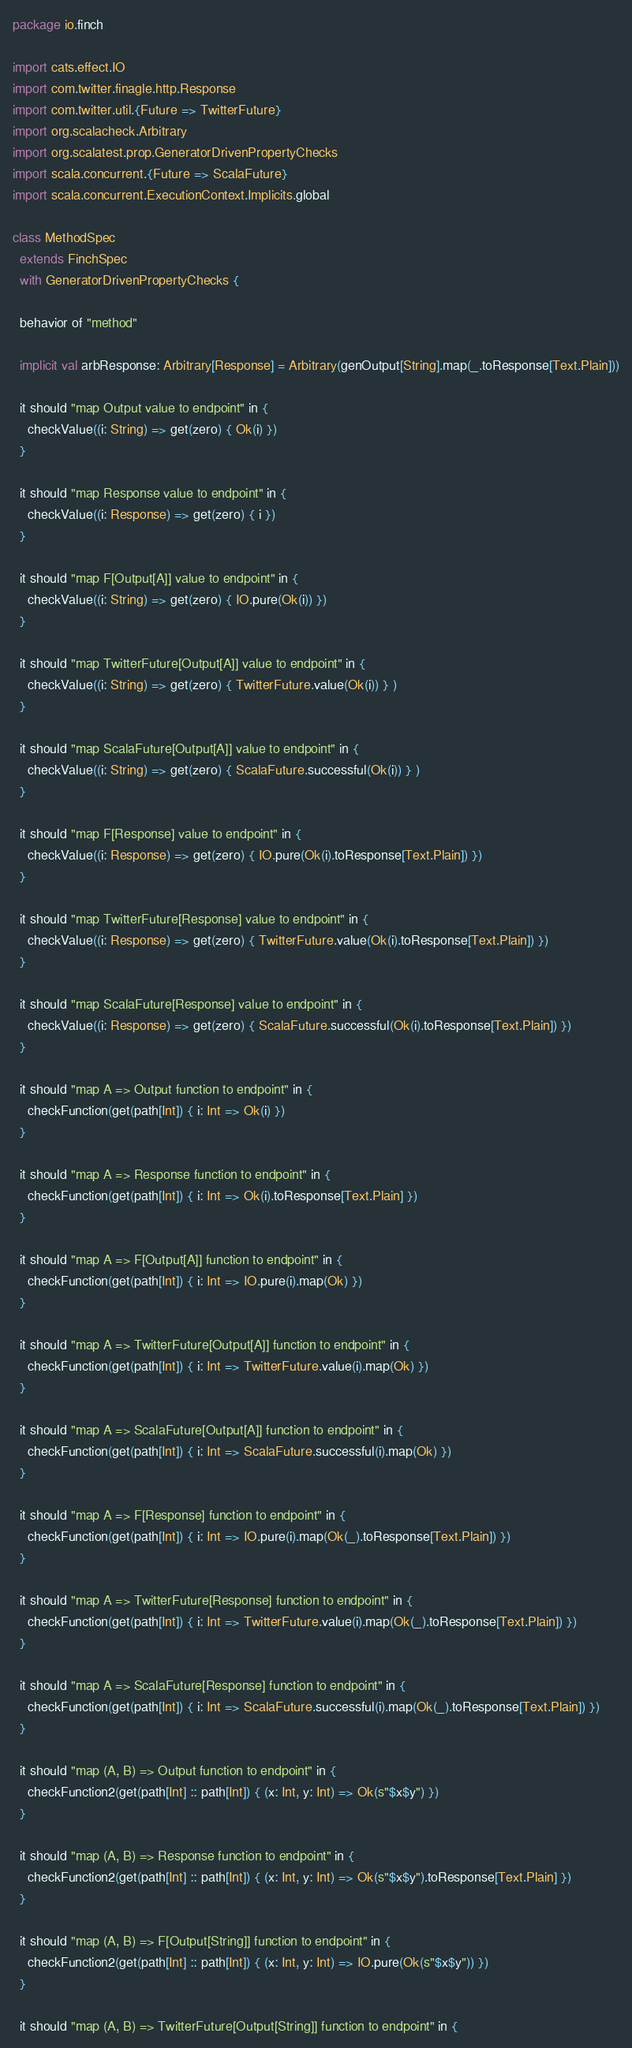Convert code to text. <code><loc_0><loc_0><loc_500><loc_500><_Scala_>package io.finch

import cats.effect.IO
import com.twitter.finagle.http.Response
import com.twitter.util.{Future => TwitterFuture}
import org.scalacheck.Arbitrary
import org.scalatest.prop.GeneratorDrivenPropertyChecks
import scala.concurrent.{Future => ScalaFuture}
import scala.concurrent.ExecutionContext.Implicits.global

class MethodSpec
  extends FinchSpec
  with GeneratorDrivenPropertyChecks {

  behavior of "method"

  implicit val arbResponse: Arbitrary[Response] = Arbitrary(genOutput[String].map(_.toResponse[Text.Plain]))

  it should "map Output value to endpoint" in {
    checkValue((i: String) => get(zero) { Ok(i) })
  }

  it should "map Response value to endpoint" in {
    checkValue((i: Response) => get(zero) { i })
  }

  it should "map F[Output[A]] value to endpoint" in {
    checkValue((i: String) => get(zero) { IO.pure(Ok(i)) })
  }

  it should "map TwitterFuture[Output[A]] value to endpoint" in {
    checkValue((i: String) => get(zero) { TwitterFuture.value(Ok(i)) } )
  }

  it should "map ScalaFuture[Output[A]] value to endpoint" in {
    checkValue((i: String) => get(zero) { ScalaFuture.successful(Ok(i)) } )
  }

  it should "map F[Response] value to endpoint" in {
    checkValue((i: Response) => get(zero) { IO.pure(Ok(i).toResponse[Text.Plain]) })
  }

  it should "map TwitterFuture[Response] value to endpoint" in {
    checkValue((i: Response) => get(zero) { TwitterFuture.value(Ok(i).toResponse[Text.Plain]) })
  }

  it should "map ScalaFuture[Response] value to endpoint" in {
    checkValue((i: Response) => get(zero) { ScalaFuture.successful(Ok(i).toResponse[Text.Plain]) })
  }

  it should "map A => Output function to endpoint" in {
    checkFunction(get(path[Int]) { i: Int => Ok(i) })
  }

  it should "map A => Response function to endpoint" in {
    checkFunction(get(path[Int]) { i: Int => Ok(i).toResponse[Text.Plain] })
  }

  it should "map A => F[Output[A]] function to endpoint" in {
    checkFunction(get(path[Int]) { i: Int => IO.pure(i).map(Ok) })
  }

  it should "map A => TwitterFuture[Output[A]] function to endpoint" in {
    checkFunction(get(path[Int]) { i: Int => TwitterFuture.value(i).map(Ok) })
  }

  it should "map A => ScalaFuture[Output[A]] function to endpoint" in {
    checkFunction(get(path[Int]) { i: Int => ScalaFuture.successful(i).map(Ok) })
  }

  it should "map A => F[Response] function to endpoint" in {
    checkFunction(get(path[Int]) { i: Int => IO.pure(i).map(Ok(_).toResponse[Text.Plain]) })
  }

  it should "map A => TwitterFuture[Response] function to endpoint" in {
    checkFunction(get(path[Int]) { i: Int => TwitterFuture.value(i).map(Ok(_).toResponse[Text.Plain]) })
  }

  it should "map A => ScalaFuture[Response] function to endpoint" in {
    checkFunction(get(path[Int]) { i: Int => ScalaFuture.successful(i).map(Ok(_).toResponse[Text.Plain]) })
  }

  it should "map (A, B) => Output function to endpoint" in {
    checkFunction2(get(path[Int] :: path[Int]) { (x: Int, y: Int) => Ok(s"$x$y") })
  }

  it should "map (A, B) => Response function to endpoint" in {
    checkFunction2(get(path[Int] :: path[Int]) { (x: Int, y: Int) => Ok(s"$x$y").toResponse[Text.Plain] })
  }

  it should "map (A, B) => F[Output[String]] function to endpoint" in {
    checkFunction2(get(path[Int] :: path[Int]) { (x: Int, y: Int) => IO.pure(Ok(s"$x$y")) })
  }

  it should "map (A, B) => TwitterFuture[Output[String]] function to endpoint" in {</code> 